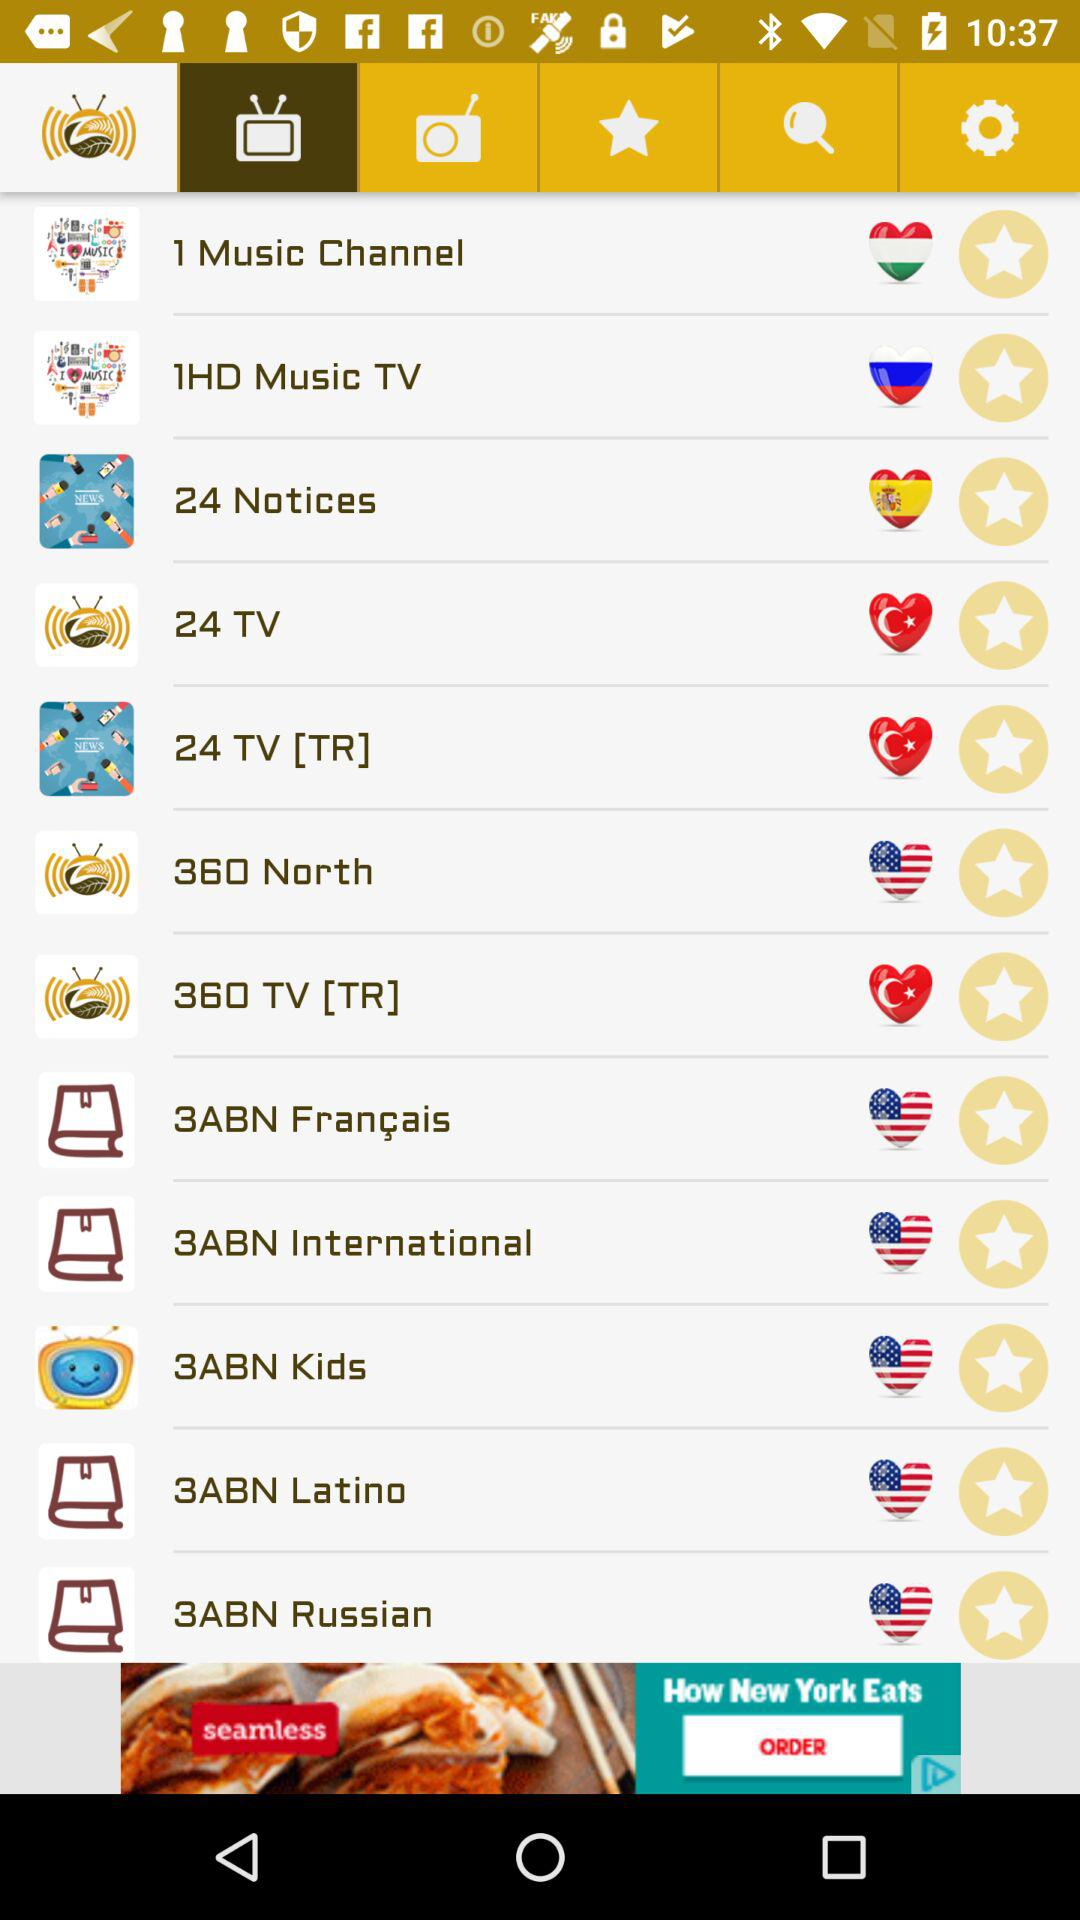How many HD music televisions are there? There is only 1 HD music television. 